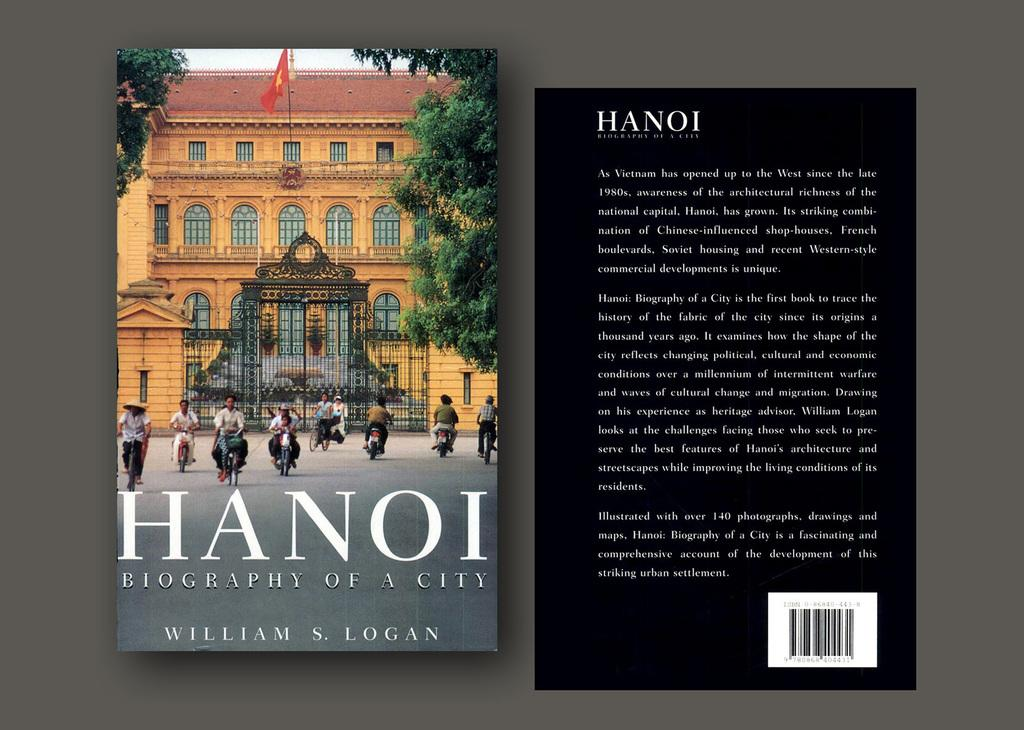Provide a one-sentence caption for the provided image. Front and back covers of HANOI book by William Logan. 